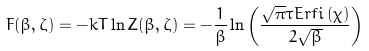<formula> <loc_0><loc_0><loc_500><loc_500>F ( \beta , \zeta ) = - k T \ln Z ( \beta , \zeta ) = - \frac { 1 } { \beta } \ln \left ( \frac { \sqrt { \pi } \tau E r f i \left ( \chi \right ) } { 2 \sqrt { \beta } } \right )</formula> 